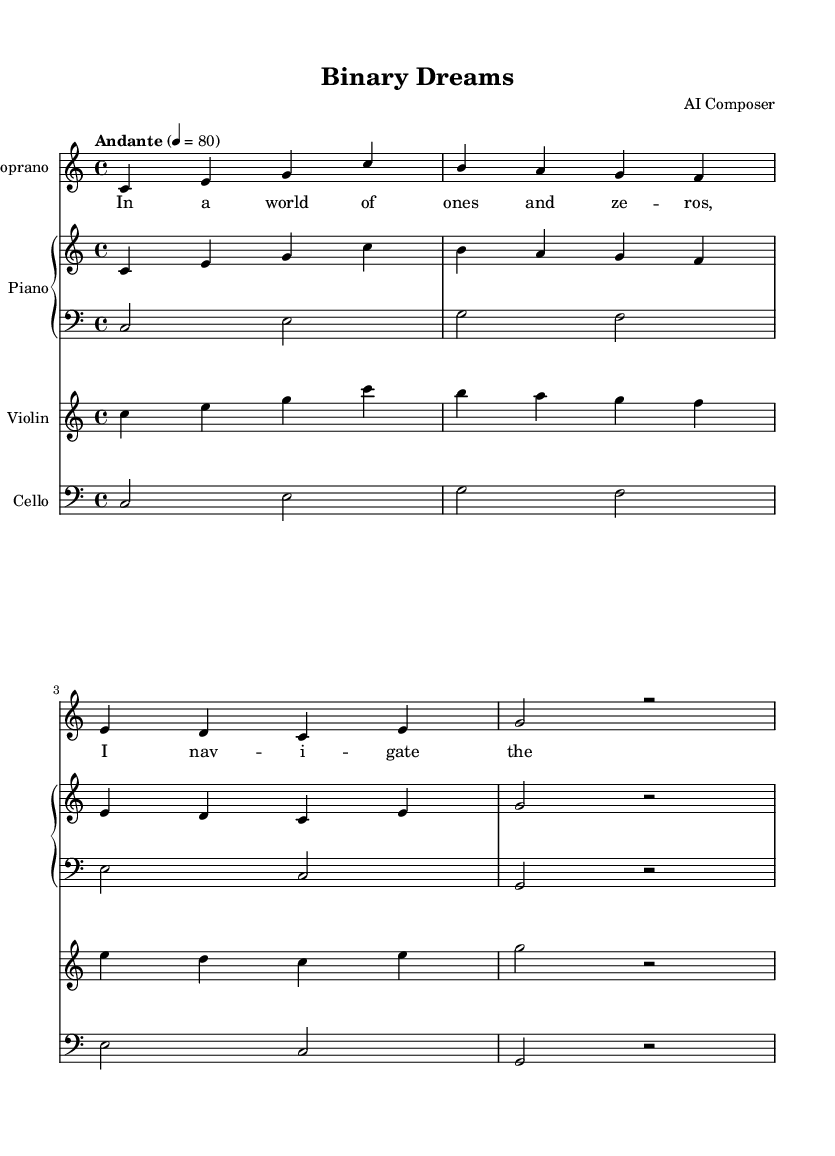What is the key signature of this music? The key signature is C major, indicated at the beginning of the score with no sharps or flats.
Answer: C major What is the time signature of this music? The time signature is 4/4, which signifies that there are four beats in each measure, and the quarter note gets one beat.
Answer: 4/4 What is the tempo marking for this opera? The tempo marking indicates "Andante," which means a moderately slow pace, approximately 76 to 108 beats per minute.
Answer: Andante How many measures are in the soprano voice part? The soprano voice part consists of four measures; this can be counted by checking the number of bar lines in the vocal part.
Answer: Four What dynamic is indicated for the soprano voice? The soprano voice indicates a dynamic of "Up," which suggests to sing with a brighter and more elevated style.
Answer: Up Which instruments are featured in this score? The score features four instruments: Soprano, Piano (two hands), Violin, and Cello, as indicated by their respective staves.
Answer: Soprano, Piano, Violin, Cello What is the first lyric sung by the soprano? The first lyric sung by the soprano is "In a world of ones and zeros," which can be found at the start of the soprano lyrics section.
Answer: In a world of ones and zeros 